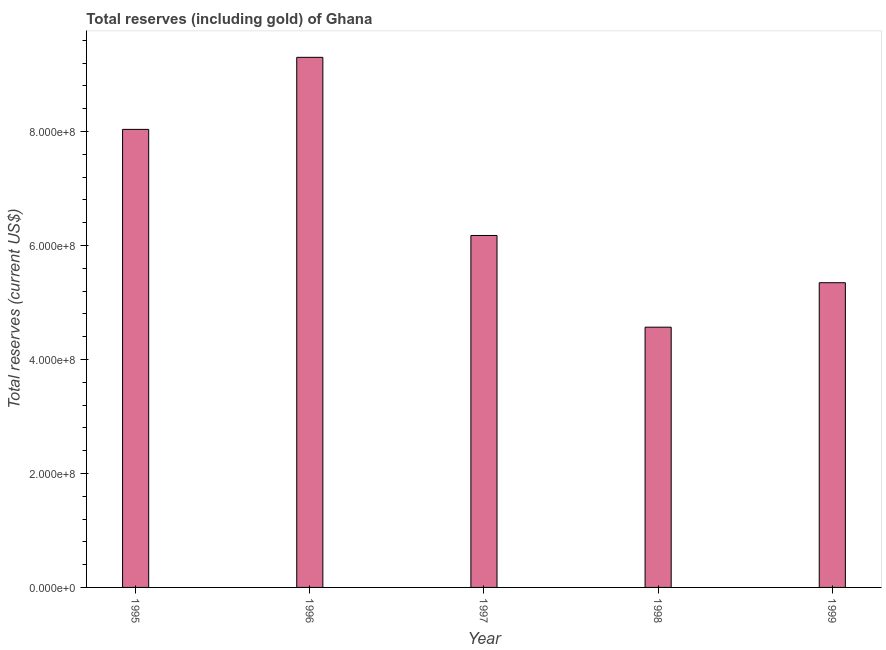Does the graph contain any zero values?
Your response must be concise. No. Does the graph contain grids?
Give a very brief answer. No. What is the title of the graph?
Provide a succinct answer. Total reserves (including gold) of Ghana. What is the label or title of the Y-axis?
Offer a very short reply. Total reserves (current US$). What is the total reserves (including gold) in 1997?
Offer a very short reply. 6.18e+08. Across all years, what is the maximum total reserves (including gold)?
Provide a succinct answer. 9.30e+08. Across all years, what is the minimum total reserves (including gold)?
Offer a very short reply. 4.57e+08. In which year was the total reserves (including gold) maximum?
Offer a terse response. 1996. In which year was the total reserves (including gold) minimum?
Your answer should be compact. 1998. What is the sum of the total reserves (including gold)?
Offer a terse response. 3.34e+09. What is the difference between the total reserves (including gold) in 1996 and 1999?
Provide a short and direct response. 3.96e+08. What is the average total reserves (including gold) per year?
Keep it short and to the point. 6.69e+08. What is the median total reserves (including gold)?
Offer a very short reply. 6.18e+08. In how many years, is the total reserves (including gold) greater than 480000000 US$?
Offer a terse response. 4. Do a majority of the years between 1995 and 1996 (inclusive) have total reserves (including gold) greater than 840000000 US$?
Give a very brief answer. No. What is the ratio of the total reserves (including gold) in 1998 to that in 1999?
Your answer should be compact. 0.85. Is the total reserves (including gold) in 1997 less than that in 1998?
Give a very brief answer. No. Is the difference between the total reserves (including gold) in 1998 and 1999 greater than the difference between any two years?
Offer a very short reply. No. What is the difference between the highest and the second highest total reserves (including gold)?
Your response must be concise. 1.26e+08. What is the difference between the highest and the lowest total reserves (including gold)?
Provide a short and direct response. 4.74e+08. How many bars are there?
Your response must be concise. 5. How many years are there in the graph?
Give a very brief answer. 5. What is the difference between two consecutive major ticks on the Y-axis?
Provide a succinct answer. 2.00e+08. What is the Total reserves (current US$) of 1995?
Your response must be concise. 8.04e+08. What is the Total reserves (current US$) in 1996?
Your answer should be very brief. 9.30e+08. What is the Total reserves (current US$) in 1997?
Your response must be concise. 6.18e+08. What is the Total reserves (current US$) in 1998?
Your response must be concise. 4.57e+08. What is the Total reserves (current US$) in 1999?
Keep it short and to the point. 5.35e+08. What is the difference between the Total reserves (current US$) in 1995 and 1996?
Give a very brief answer. -1.26e+08. What is the difference between the Total reserves (current US$) in 1995 and 1997?
Give a very brief answer. 1.86e+08. What is the difference between the Total reserves (current US$) in 1995 and 1998?
Offer a very short reply. 3.47e+08. What is the difference between the Total reserves (current US$) in 1995 and 1999?
Your response must be concise. 2.69e+08. What is the difference between the Total reserves (current US$) in 1996 and 1997?
Make the answer very short. 3.13e+08. What is the difference between the Total reserves (current US$) in 1996 and 1998?
Ensure brevity in your answer.  4.74e+08. What is the difference between the Total reserves (current US$) in 1996 and 1999?
Provide a short and direct response. 3.96e+08. What is the difference between the Total reserves (current US$) in 1997 and 1998?
Offer a very short reply. 1.61e+08. What is the difference between the Total reserves (current US$) in 1997 and 1999?
Ensure brevity in your answer.  8.29e+07. What is the difference between the Total reserves (current US$) in 1998 and 1999?
Make the answer very short. -7.81e+07. What is the ratio of the Total reserves (current US$) in 1995 to that in 1996?
Offer a very short reply. 0.86. What is the ratio of the Total reserves (current US$) in 1995 to that in 1997?
Your answer should be compact. 1.3. What is the ratio of the Total reserves (current US$) in 1995 to that in 1998?
Keep it short and to the point. 1.76. What is the ratio of the Total reserves (current US$) in 1995 to that in 1999?
Provide a short and direct response. 1.5. What is the ratio of the Total reserves (current US$) in 1996 to that in 1997?
Your response must be concise. 1.51. What is the ratio of the Total reserves (current US$) in 1996 to that in 1998?
Make the answer very short. 2.04. What is the ratio of the Total reserves (current US$) in 1996 to that in 1999?
Keep it short and to the point. 1.74. What is the ratio of the Total reserves (current US$) in 1997 to that in 1998?
Provide a succinct answer. 1.35. What is the ratio of the Total reserves (current US$) in 1997 to that in 1999?
Your answer should be very brief. 1.16. What is the ratio of the Total reserves (current US$) in 1998 to that in 1999?
Make the answer very short. 0.85. 